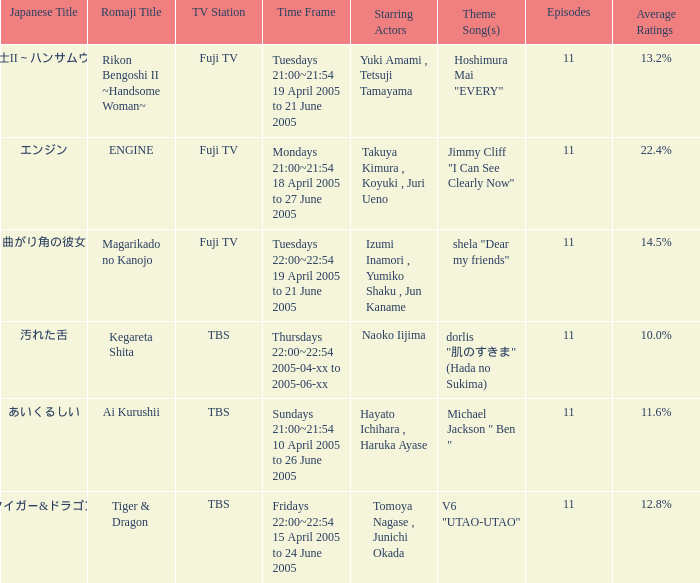What is the theme song for Magarikado no Kanojo? Shela "dear my friends". 